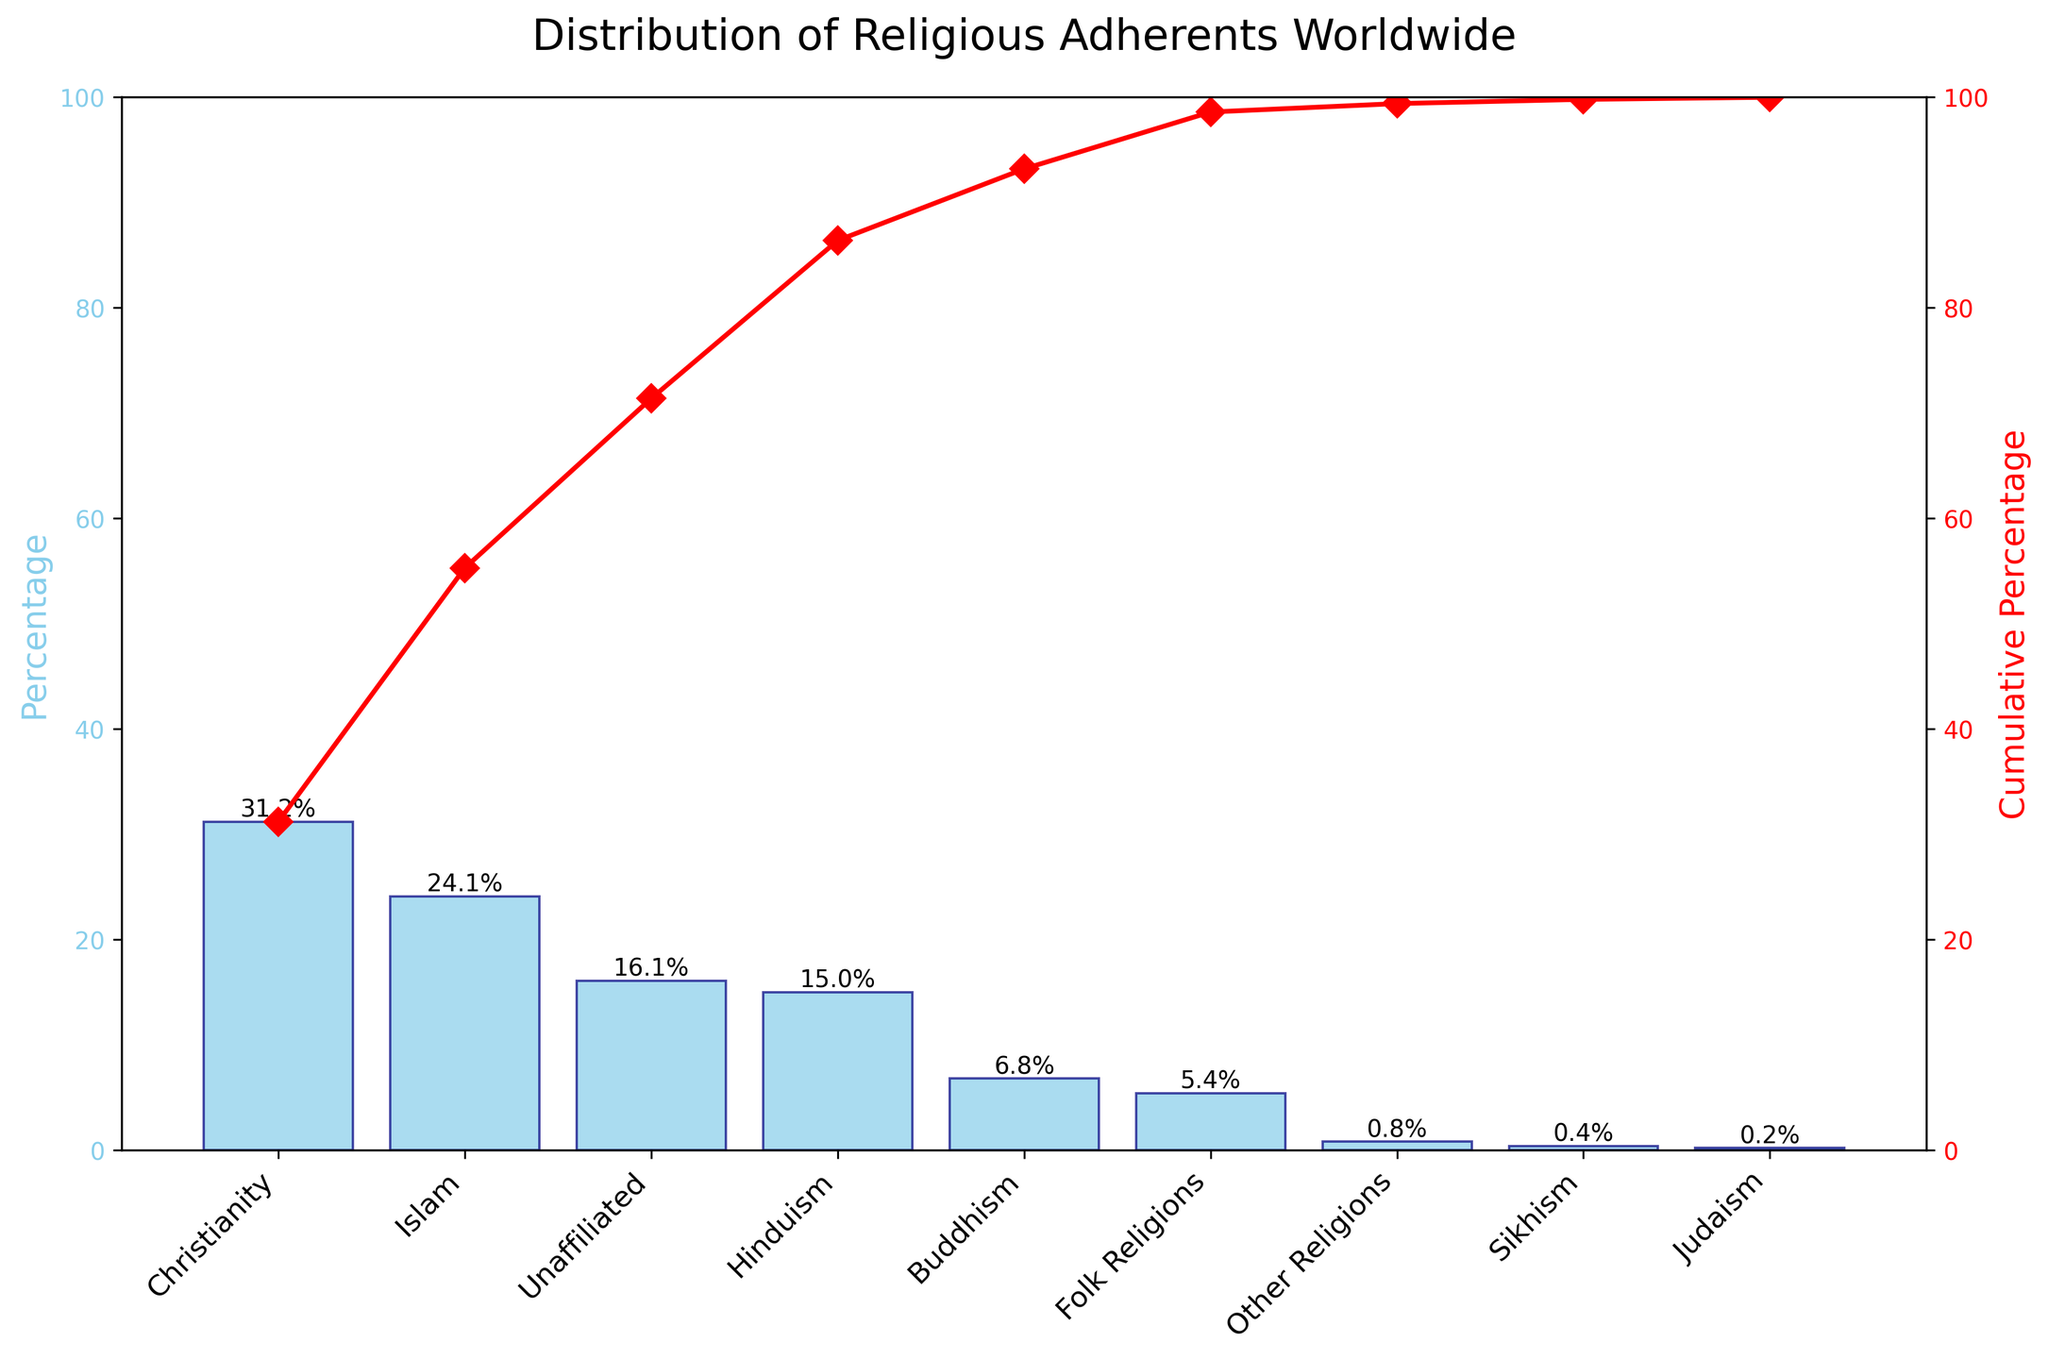what is the title of the chart? The title of the chart is clearly displayed at the top of the figure. It indicates what the chart is about.
Answer: Distribution of Religious Adherents Worldwide What percentage of the world adheres to Christianity? The percentage values for each religion are marked at the top of each bar, and ‘Christianity’ has 31.2% displayed.
Answer: 31.2% Which two religions have the highest number of adherents? The height of the bars represents the number of adherents, and Christianity and Islam have the tallest bars indicating the largest percentages.
Answer: Christianity and Islam How many religions have a percentage greater than 10%? To identify this, observe the bars and their percentage labels. Three bars indicate percentages greater than 10%: Christianity, Islam, and Hinduism.
Answer: 3 What is the percentage of the Unaffiliated group? The Unaffiliated group is displayed with its respective bar and percentage label, which is 16.1%.
Answer: 16.1% What is the cumulative percentage after including Buddhism? The cumulative line and its markers show the cumulative percentage as each religion is added. After Buddhism, the cumulative percentage reaches 77.1% (adding Buddhism to the previous cumulative, which is 70.3%).
Answer: 77.1% What is the gap in percentage between Hinduism and the Unaffiliated group? The percentage of Hinduism is 15.0% and for Unaffiliated it is 16.1%. Subtract the lower from the higher percentage: 16.1% - 15.0%.
Answer: 1.1% By how much does Sikhism's percentage exceed Judaism's percentage? Sikhism has 0.4% and Judaism has 0.2%. The difference is 0.4% - 0.2%.
Answer: 0.2% Which religion's adherents collectively form a cumulative percentage closest to 50% without exceeding it? Examining the cumulative line, Islam's adherents bring the cumulative percentage to 55.3%, but adding all percentages up to Hinduism brings it to 70.3%. Therefore, Islam is the closest without exceeding 50%.
Answer: Islam What is the total percentage covered by Christianity, Islam, and Hinduism together? Adding the percentages for Christianity (31.2%), Islam (24.1%), and Hinduism (15.0%) gives: 31.2% + 24.1% + 15.0%.
Answer: 70.3% 